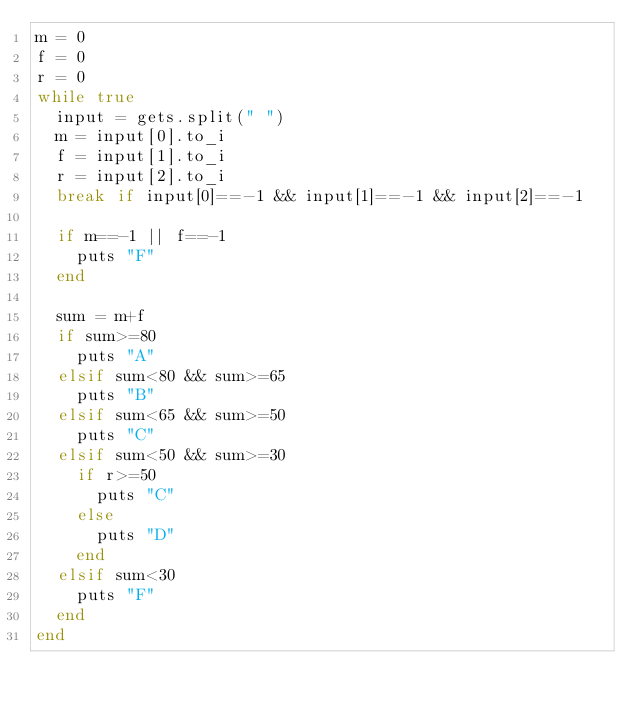<code> <loc_0><loc_0><loc_500><loc_500><_Ruby_>m = 0
f = 0
r = 0
while true 
  input = gets.split(" ")
  m = input[0].to_i
  f = input[1].to_i
  r = input[2].to_i
  break if input[0]==-1 && input[1]==-1 && input[2]==-1
  
  if m==-1 || f==-1
    puts "F"
  end

  sum = m+f
  if sum>=80
    puts "A"
  elsif sum<80 && sum>=65
    puts "B"
  elsif sum<65 && sum>=50
    puts "C"
  elsif sum<50 && sum>=30
    if r>=50
      puts "C"
    else
      puts "D"
    end
  elsif sum<30
    puts "F"
  end
end</code> 